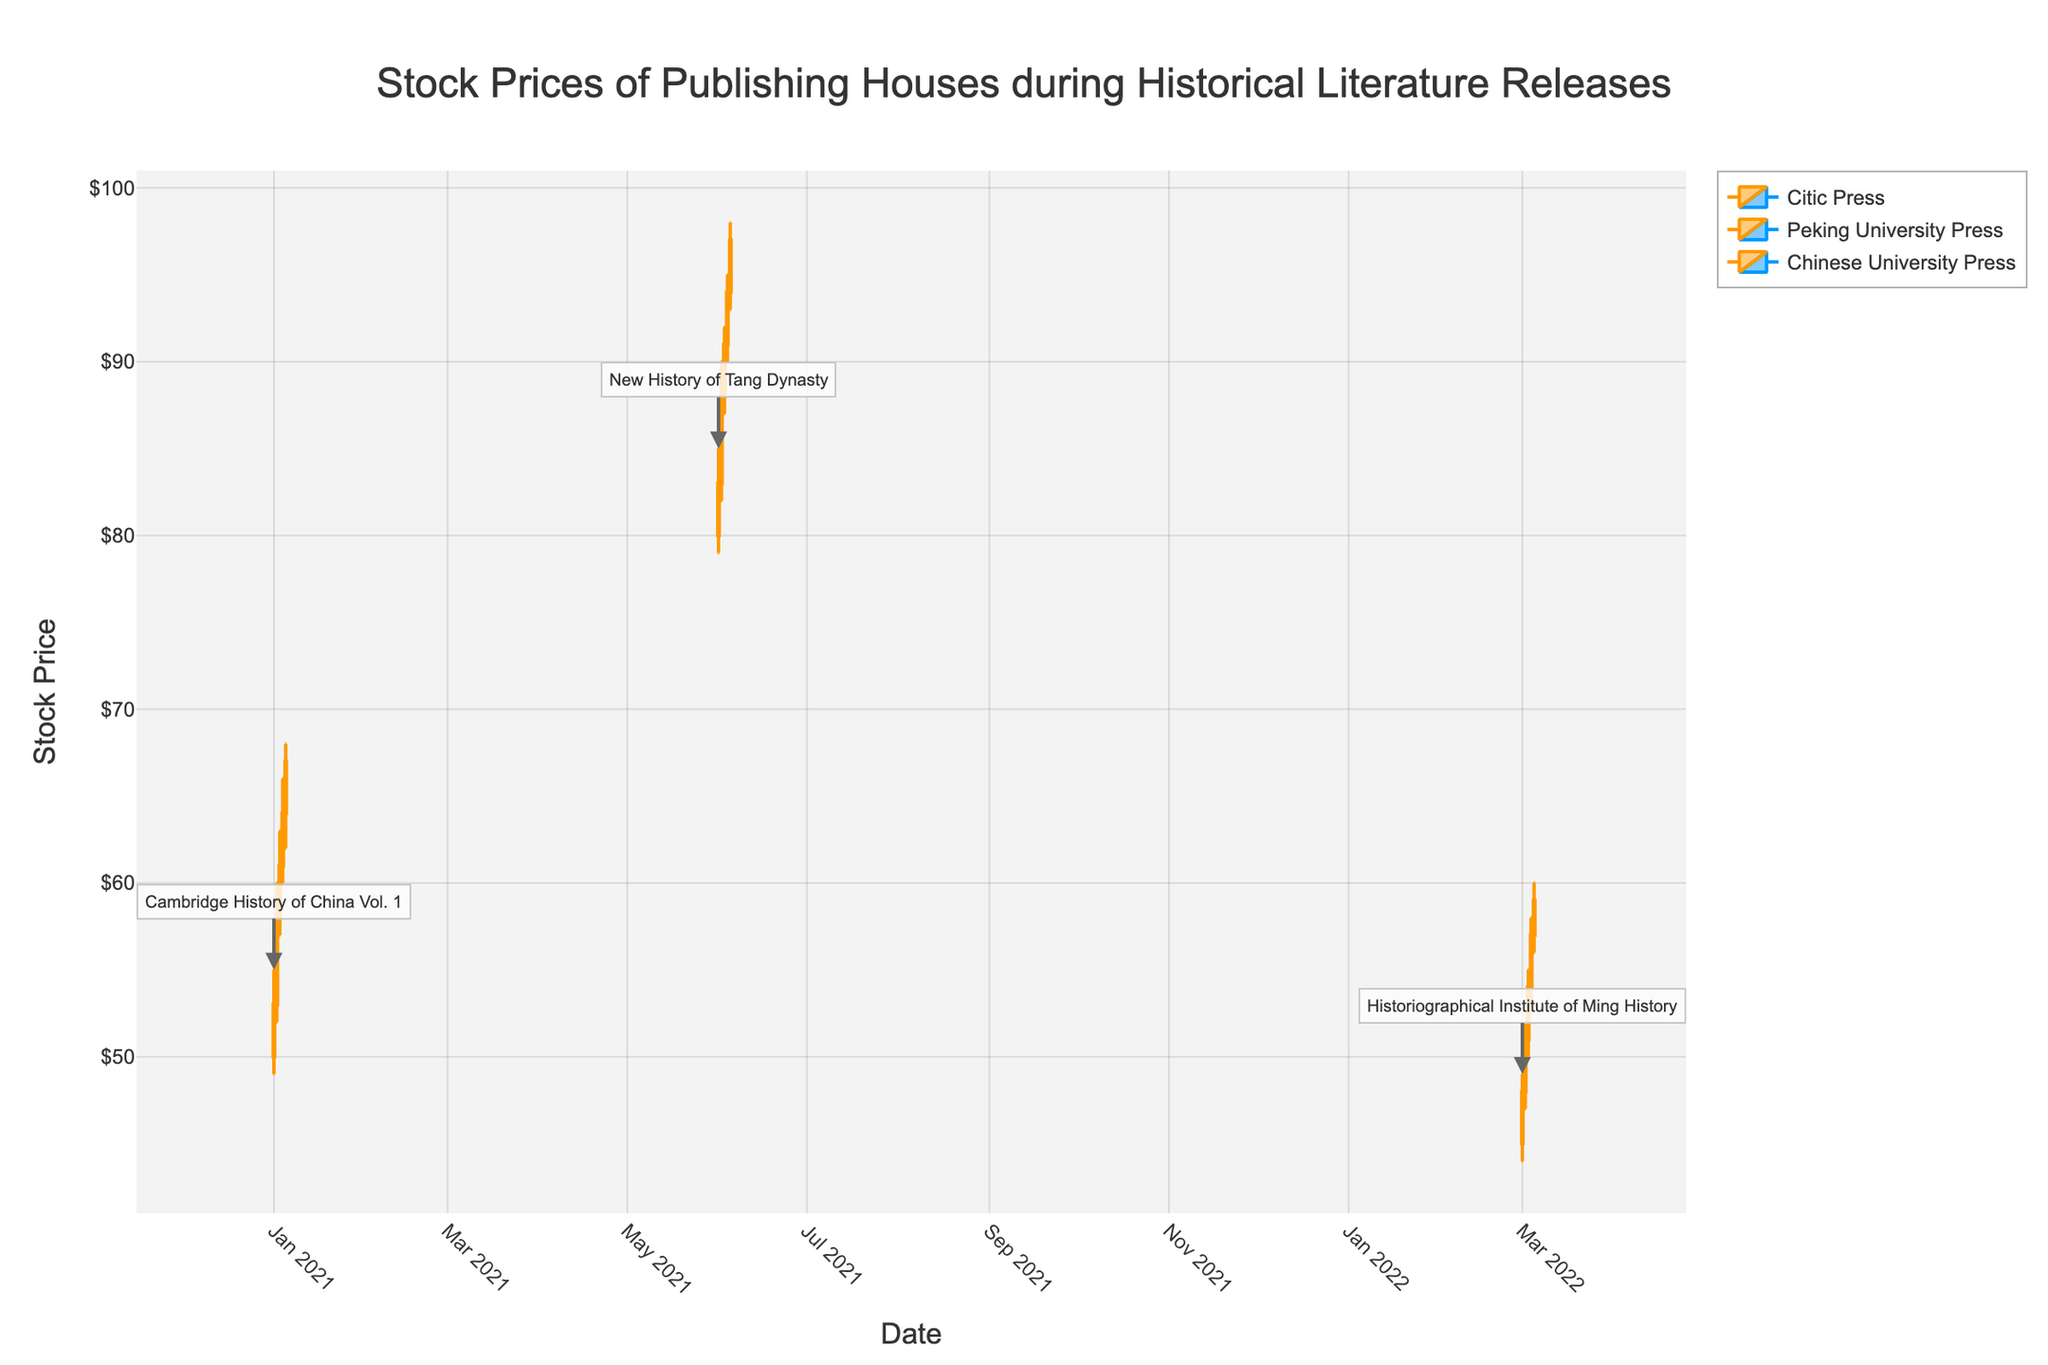What's the title of the figure? The title is displayed at the top of the figure. It provides an overview of the data being visualized.
Answer: Stock Prices of Publishing Houses during Historical Literature Releases What's the highest stock price recorded for Chinese University Press? To find the highest price, look at the highest candlestick wick for Chinese University Press.
Answer: $60 During the release of "New History of Tang Dynasty," what was the highest volume of stocks traded? Look at the volume annotations on the x-axis for Peking University Press during the specified period. The highest value is on the date with the maximum candlestick height.
Answer: 30,000 Compare the closing prices of Citic Press on 2021-01-02 and Chinese University Press on 2022-03-05. Which one is higher? Check the close prices shown by the top boundary of the body of the candlestick for each date specified and compare them. 2021-01-02 has a close price of $58 and 2022-03-05 has a close price of $59.
Answer: Chinese University Press What is the average closing price of Peking University Press during the release of "New History of Tang Dynasty"? Add all closing prices during the specified period and divide by the number of trading days. (83 + 88 + 91 + 94 + 97) / 5 = 453 / 5
Answer: $90.6 What is the common color for increasing and decreasing candlesticks? Identify the colors used for both increasing and decreasing candlesticks by observing multiple candlesticks. Increasing are orange, and decreasing are blue.
Answer: Orange and Blue What is the range of stock prices for "Cambridge History of China Vol. 1" on 2021-01-04? Calculate the difference between the high and low prices for that date: 66 - 60 = 6.
Answer: $6 Which publishing house shows the most significant upward trend based on the candlestick plot? Identify the house with the most consistently increasing closing prices and higher maximum peaks.
Answer: Peking University Press How many trading days are present for the release of "Historiographical Institute of Ming History"? Count the number of dates listed under Chinese University Press in the data provided.
Answer: 5 